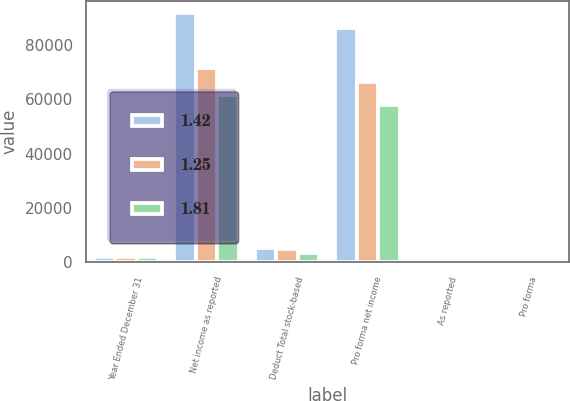Convert chart. <chart><loc_0><loc_0><loc_500><loc_500><stacked_bar_chart><ecel><fcel>Year Ended December 31<fcel>Net income as reported<fcel>Deduct Total stock-based<fcel>Pro forma net income<fcel>As reported<fcel>Pro forma<nl><fcel>1.42<fcel>2003<fcel>91696<fcel>5374<fcel>86322<fcel>1.95<fcel>1.83<nl><fcel>1.25<fcel>2002<fcel>71595<fcel>5102<fcel>66493<fcel>1.54<fcel>1.43<nl><fcel>1.81<fcel>2001<fcel>61529<fcel>3558<fcel>57971<fcel>1.34<fcel>1.26<nl></chart> 